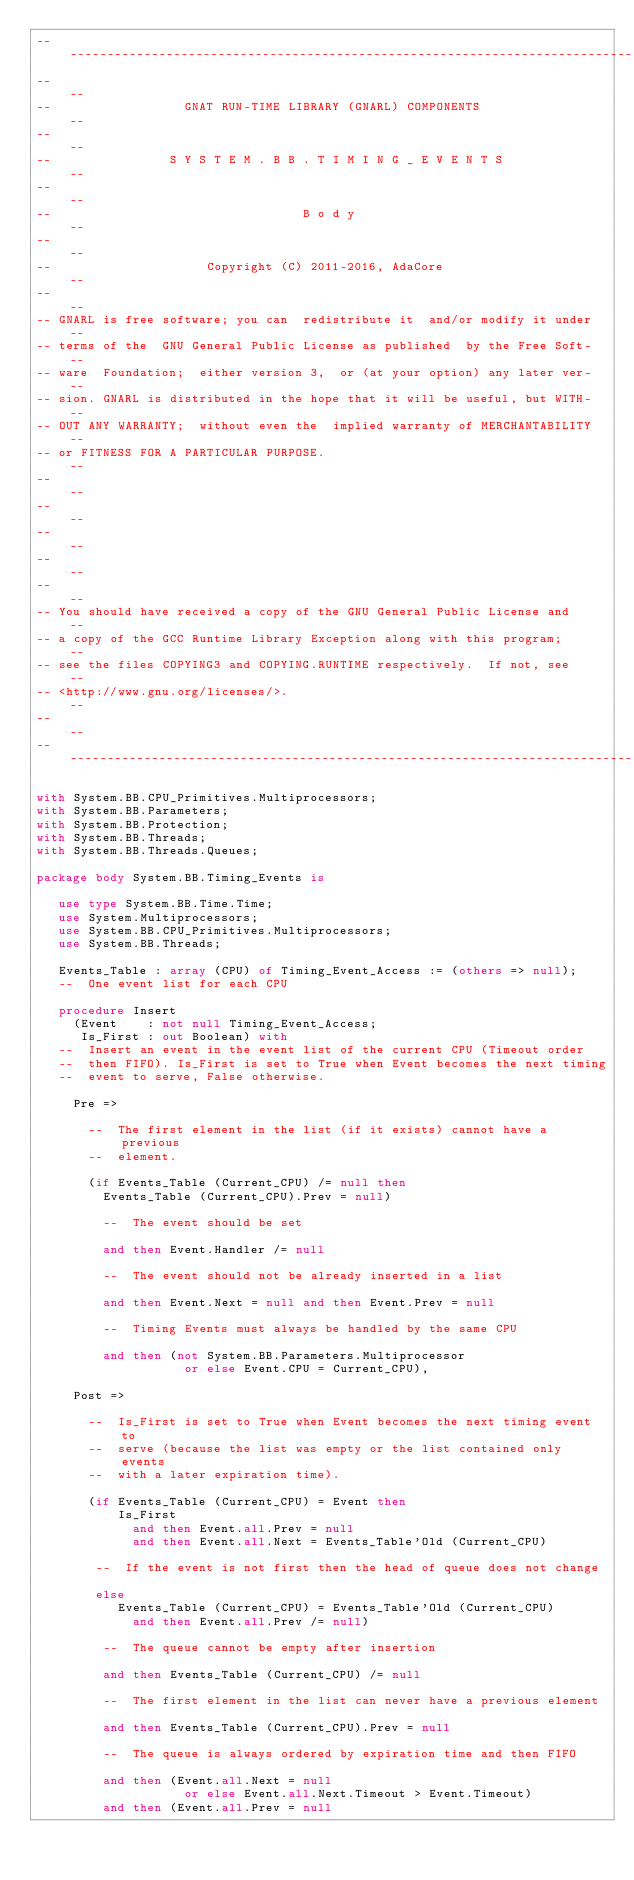Convert code to text. <code><loc_0><loc_0><loc_500><loc_500><_Ada_>------------------------------------------------------------------------------
--                                                                          --
--                  GNAT RUN-TIME LIBRARY (GNARL) COMPONENTS                --
--                                                                          --
--                S Y S T E M . B B . T I M I N G _ E V E N T S             --
--                                                                          --
--                                  B o d y                                 --
--                                                                          --
--                     Copyright (C) 2011-2016, AdaCore                     --
--                                                                          --
-- GNARL is free software; you can  redistribute it  and/or modify it under --
-- terms of the  GNU General Public License as published  by the Free Soft- --
-- ware  Foundation;  either version 3,  or (at your option) any later ver- --
-- sion. GNARL is distributed in the hope that it will be useful, but WITH- --
-- OUT ANY WARRANTY;  without even the  implied warranty of MERCHANTABILITY --
-- or FITNESS FOR A PARTICULAR PURPOSE.                                     --
--                                                                          --
--                                                                          --
--                                                                          --
--                                                                          --
--                                                                          --
-- You should have received a copy of the GNU General Public License and    --
-- a copy of the GCC Runtime Library Exception along with this program;     --
-- see the files COPYING3 and COPYING.RUNTIME respectively.  If not, see    --
-- <http://www.gnu.org/licenses/>.                                          --
--                                                                          --
------------------------------------------------------------------------------

with System.BB.CPU_Primitives.Multiprocessors;
with System.BB.Parameters;
with System.BB.Protection;
with System.BB.Threads;
with System.BB.Threads.Queues;

package body System.BB.Timing_Events is

   use type System.BB.Time.Time;
   use System.Multiprocessors;
   use System.BB.CPU_Primitives.Multiprocessors;
   use System.BB.Threads;

   Events_Table : array (CPU) of Timing_Event_Access := (others => null);
   --  One event list for each CPU

   procedure Insert
     (Event    : not null Timing_Event_Access;
      Is_First : out Boolean) with
   --  Insert an event in the event list of the current CPU (Timeout order
   --  then FIFO). Is_First is set to True when Event becomes the next timing
   --  event to serve, False otherwise.

     Pre =>

       --  The first element in the list (if it exists) cannot have a previous
       --  element.

       (if Events_Table (Current_CPU) /= null then
         Events_Table (Current_CPU).Prev = null)

         --  The event should be set

         and then Event.Handler /= null

         --  The event should not be already inserted in a list

         and then Event.Next = null and then Event.Prev = null

         --  Timing Events must always be handled by the same CPU

         and then (not System.BB.Parameters.Multiprocessor
                    or else Event.CPU = Current_CPU),

     Post =>

       --  Is_First is set to True when Event becomes the next timing event to
       --  serve (because the list was empty or the list contained only events
       --  with a later expiration time).

       (if Events_Table (Current_CPU) = Event then
           Is_First
             and then Event.all.Prev = null
             and then Event.all.Next = Events_Table'Old (Current_CPU)

        --  If the event is not first then the head of queue does not change

        else
           Events_Table (Current_CPU) = Events_Table'Old (Current_CPU)
             and then Event.all.Prev /= null)

         --  The queue cannot be empty after insertion

         and then Events_Table (Current_CPU) /= null

         --  The first element in the list can never have a previous element

         and then Events_Table (Current_CPU).Prev = null

         --  The queue is always ordered by expiration time and then FIFO

         and then (Event.all.Next = null
                    or else Event.all.Next.Timeout > Event.Timeout)
         and then (Event.all.Prev = null</code> 